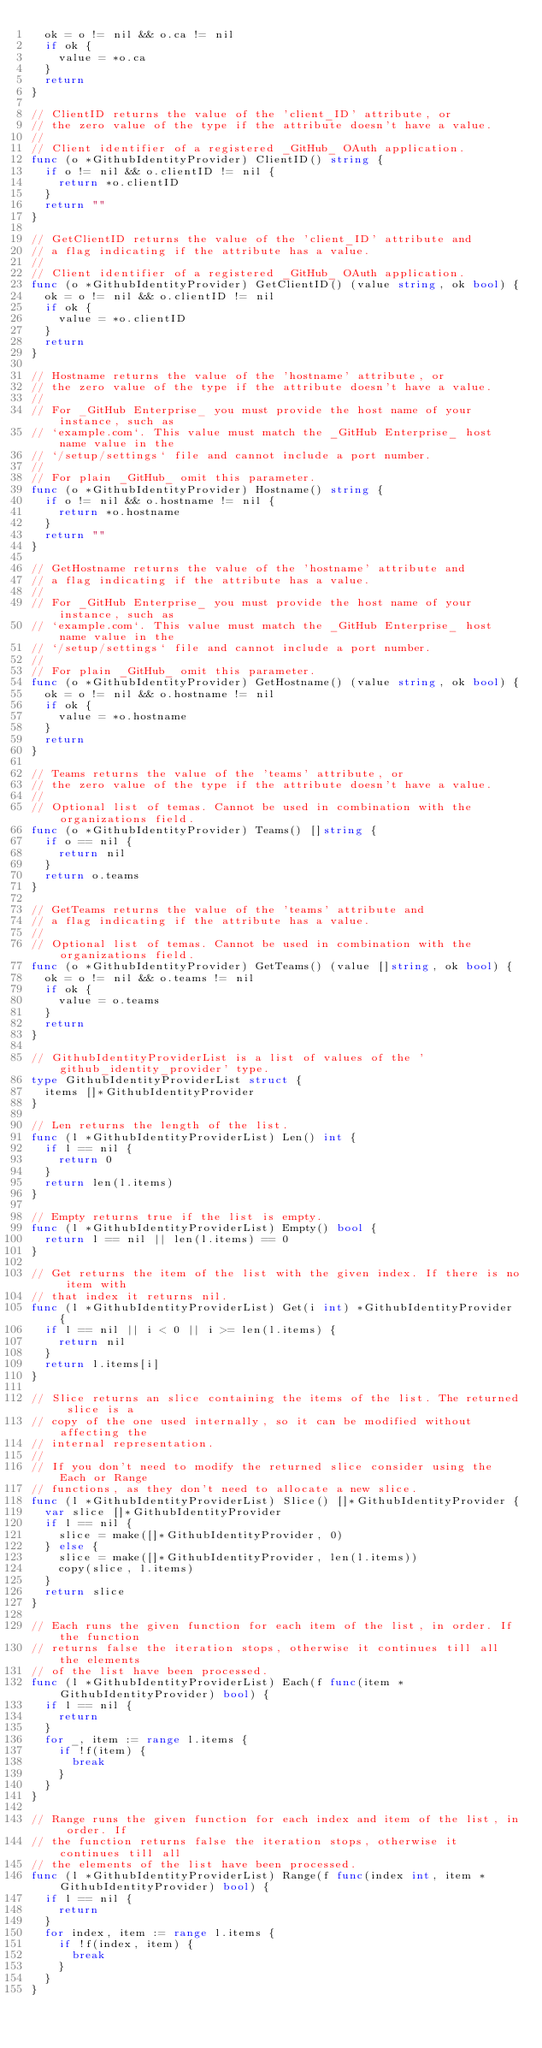Convert code to text. <code><loc_0><loc_0><loc_500><loc_500><_Go_>	ok = o != nil && o.ca != nil
	if ok {
		value = *o.ca
	}
	return
}

// ClientID returns the value of the 'client_ID' attribute, or
// the zero value of the type if the attribute doesn't have a value.
//
// Client identifier of a registered _GitHub_ OAuth application.
func (o *GithubIdentityProvider) ClientID() string {
	if o != nil && o.clientID != nil {
		return *o.clientID
	}
	return ""
}

// GetClientID returns the value of the 'client_ID' attribute and
// a flag indicating if the attribute has a value.
//
// Client identifier of a registered _GitHub_ OAuth application.
func (o *GithubIdentityProvider) GetClientID() (value string, ok bool) {
	ok = o != nil && o.clientID != nil
	if ok {
		value = *o.clientID
	}
	return
}

// Hostname returns the value of the 'hostname' attribute, or
// the zero value of the type if the attribute doesn't have a value.
//
// For _GitHub Enterprise_ you must provide the host name of your instance, such as
// `example.com`. This value must match the _GitHub Enterprise_ host name value in the
// `/setup/settings` file and cannot include a port number.
//
// For plain _GitHub_ omit this parameter.
func (o *GithubIdentityProvider) Hostname() string {
	if o != nil && o.hostname != nil {
		return *o.hostname
	}
	return ""
}

// GetHostname returns the value of the 'hostname' attribute and
// a flag indicating if the attribute has a value.
//
// For _GitHub Enterprise_ you must provide the host name of your instance, such as
// `example.com`. This value must match the _GitHub Enterprise_ host name value in the
// `/setup/settings` file and cannot include a port number.
//
// For plain _GitHub_ omit this parameter.
func (o *GithubIdentityProvider) GetHostname() (value string, ok bool) {
	ok = o != nil && o.hostname != nil
	if ok {
		value = *o.hostname
	}
	return
}

// Teams returns the value of the 'teams' attribute, or
// the zero value of the type if the attribute doesn't have a value.
//
// Optional list of temas. Cannot be used in combination with the organizations field.
func (o *GithubIdentityProvider) Teams() []string {
	if o == nil {
		return nil
	}
	return o.teams
}

// GetTeams returns the value of the 'teams' attribute and
// a flag indicating if the attribute has a value.
//
// Optional list of temas. Cannot be used in combination with the organizations field.
func (o *GithubIdentityProvider) GetTeams() (value []string, ok bool) {
	ok = o != nil && o.teams != nil
	if ok {
		value = o.teams
	}
	return
}

// GithubIdentityProviderList is a list of values of the 'github_identity_provider' type.
type GithubIdentityProviderList struct {
	items []*GithubIdentityProvider
}

// Len returns the length of the list.
func (l *GithubIdentityProviderList) Len() int {
	if l == nil {
		return 0
	}
	return len(l.items)
}

// Empty returns true if the list is empty.
func (l *GithubIdentityProviderList) Empty() bool {
	return l == nil || len(l.items) == 0
}

// Get returns the item of the list with the given index. If there is no item with
// that index it returns nil.
func (l *GithubIdentityProviderList) Get(i int) *GithubIdentityProvider {
	if l == nil || i < 0 || i >= len(l.items) {
		return nil
	}
	return l.items[i]
}

// Slice returns an slice containing the items of the list. The returned slice is a
// copy of the one used internally, so it can be modified without affecting the
// internal representation.
//
// If you don't need to modify the returned slice consider using the Each or Range
// functions, as they don't need to allocate a new slice.
func (l *GithubIdentityProviderList) Slice() []*GithubIdentityProvider {
	var slice []*GithubIdentityProvider
	if l == nil {
		slice = make([]*GithubIdentityProvider, 0)
	} else {
		slice = make([]*GithubIdentityProvider, len(l.items))
		copy(slice, l.items)
	}
	return slice
}

// Each runs the given function for each item of the list, in order. If the function
// returns false the iteration stops, otherwise it continues till all the elements
// of the list have been processed.
func (l *GithubIdentityProviderList) Each(f func(item *GithubIdentityProvider) bool) {
	if l == nil {
		return
	}
	for _, item := range l.items {
		if !f(item) {
			break
		}
	}
}

// Range runs the given function for each index and item of the list, in order. If
// the function returns false the iteration stops, otherwise it continues till all
// the elements of the list have been processed.
func (l *GithubIdentityProviderList) Range(f func(index int, item *GithubIdentityProvider) bool) {
	if l == nil {
		return
	}
	for index, item := range l.items {
		if !f(index, item) {
			break
		}
	}
}
</code> 